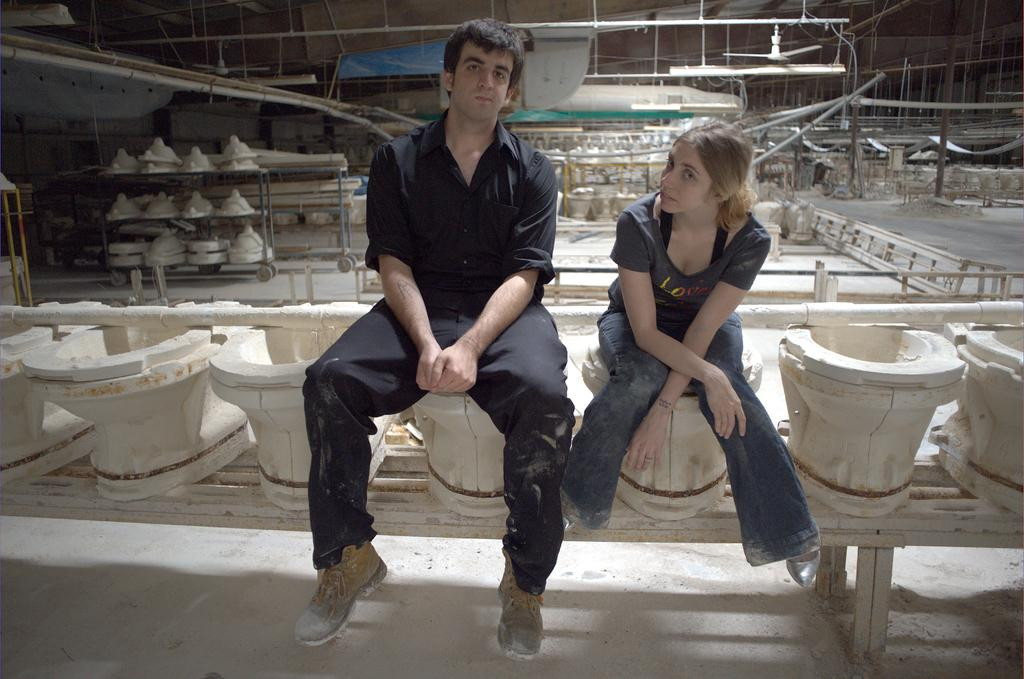How many persons are sitting on the toilet seat in the image? There are two persons sitting on the toilet seat in the image. What can be seen in the background of the image? There are toilet seats in a trolley at the back. What is visible at the top of the image? There is a light and a fan at the top of the image. What type of dinosaurs can be seen roaming around in the image? There are no dinosaurs present in the image. What reward can be seen for the persons sitting on the toilet seat in the image? There is no reward visible in the image; it only shows two persons sitting on the toilet seat and toilet seats in a trolley. 